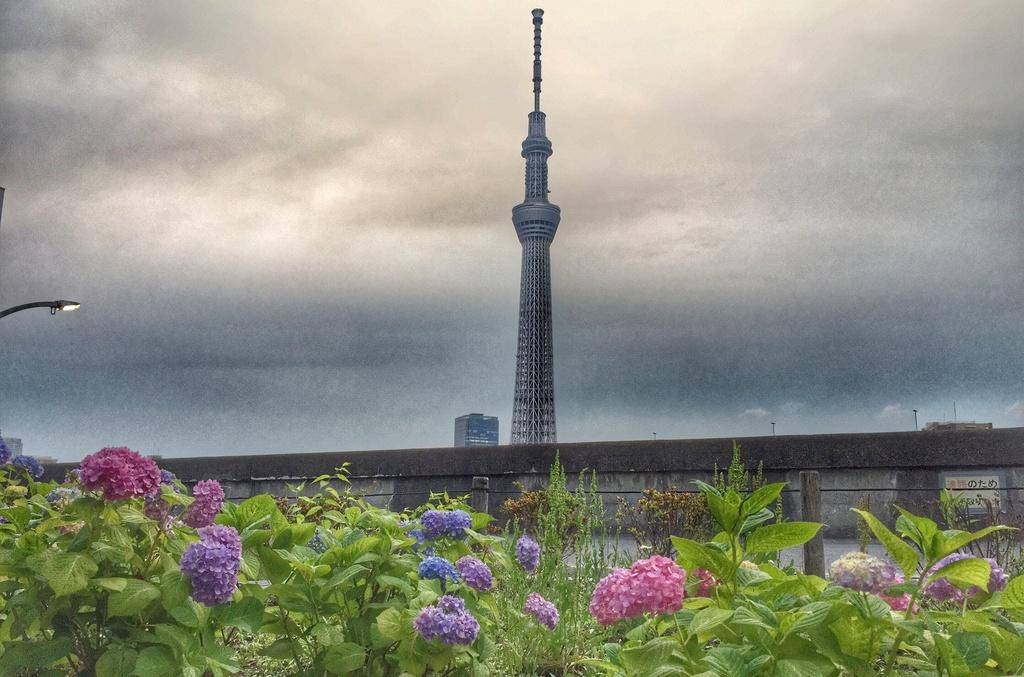What type of plants can be seen in the image? There are plants with flowers in the image. What is the background of the image? There is a wall in the image. What type of artificial light source is present in the image? There is a street light in the image. What type of structure can be seen in the image? There is a building in the image. What tall structure is present in the image? There is a tower in the image. What part of the natural environment is visible in the image? The sky is visible in the image. What type of behavior can be observed in the rose in the image? There is no rose present in the image, so no behavior can be observed. Where is the dock located in the image? There is no dock present in the image. 